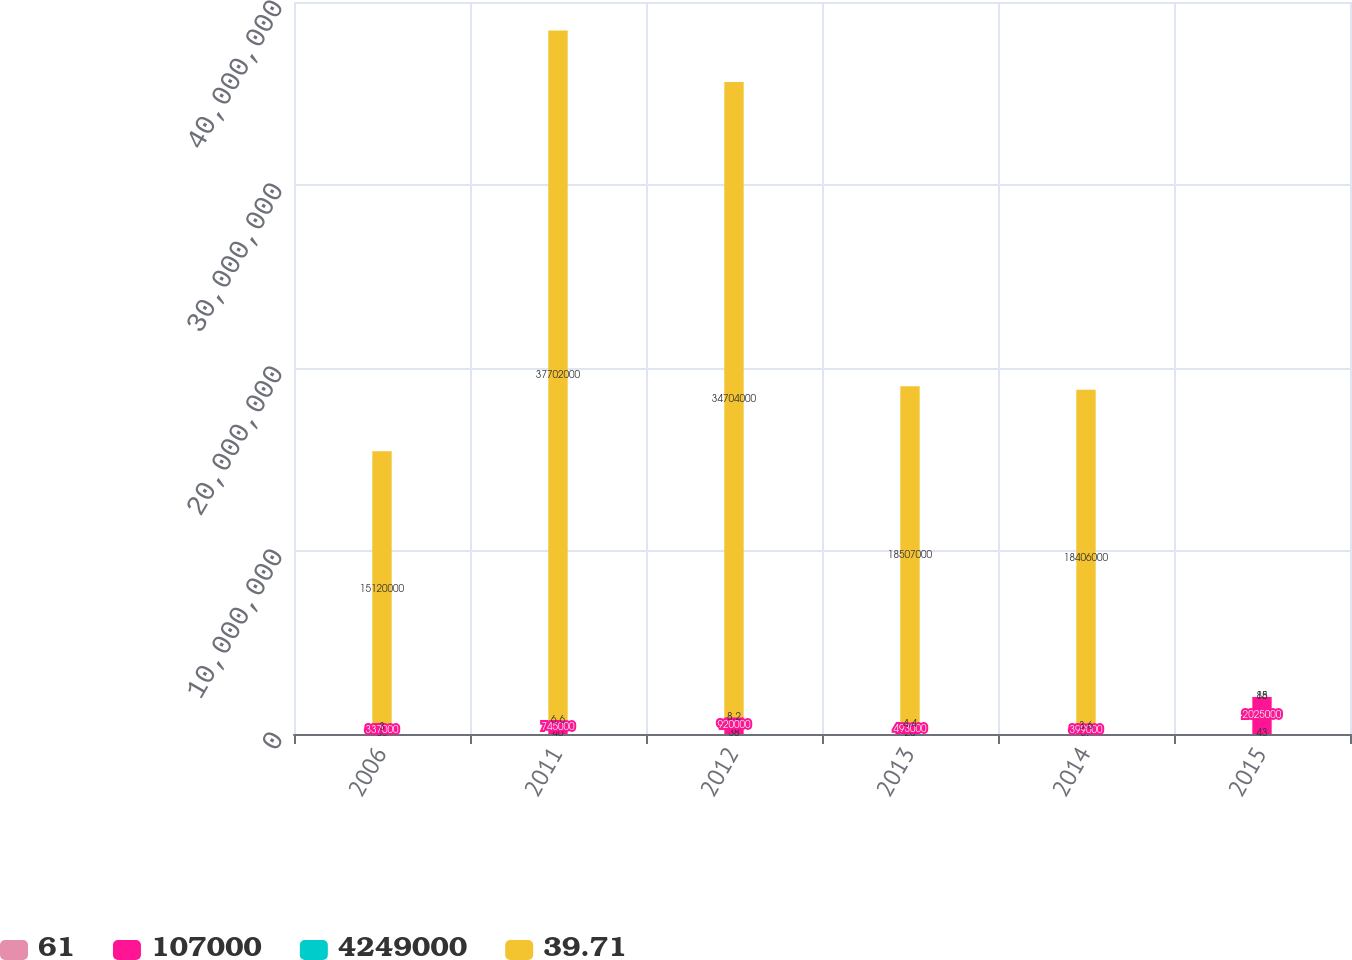Convert chart. <chart><loc_0><loc_0><loc_500><loc_500><stacked_bar_chart><ecel><fcel>2006<fcel>2011<fcel>2012<fcel>2013<fcel>2014<fcel>2015<nl><fcel>61<fcel>85<fcel>40<fcel>38<fcel>20<fcel>37<fcel>43<nl><fcel>107000<fcel>337000<fcel>745000<fcel>920000<fcel>493000<fcel>399000<fcel>2.025e+06<nl><fcel>4.249e+06<fcel>3<fcel>6.6<fcel>8.2<fcel>4.4<fcel>3.6<fcel>18<nl><fcel>39.71<fcel>1.512e+07<fcel>3.7702e+07<fcel>3.4704e+07<fcel>1.8507e+07<fcel>1.8406e+07<fcel>85<nl></chart> 